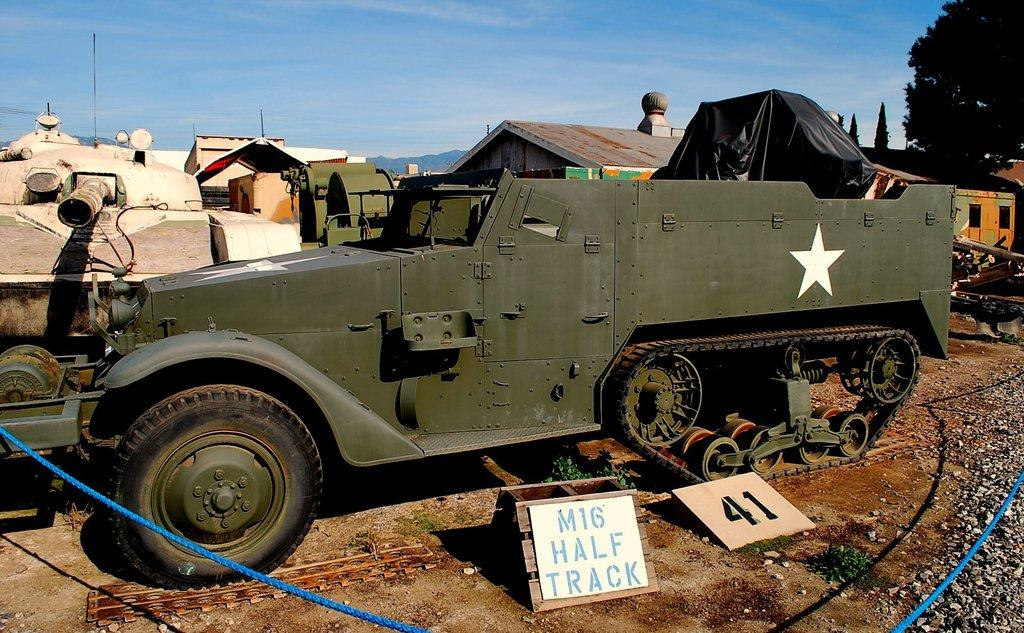What type of objects can be seen on the ground in the image? There are motor vehicles placed on the ground in the image. What other elements can be found in the image besides motor vehicles? There are shrubs, stones, pipelines, ropes, a building, trees, and the sky visible in the image. Can you describe the sky in the image? The sky is visible in the image, and there are clouds present. What type of oatmeal is being served to the cattle in the image? There are no cattle or oatmeal present in the image. 